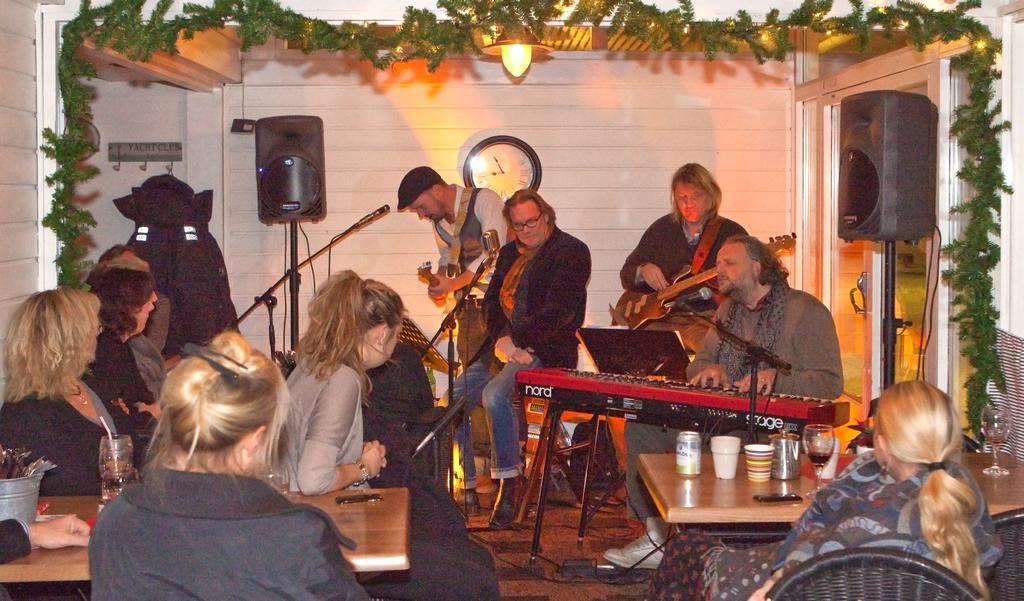In one or two sentences, can you explain what this image depicts? In the foreground of this image, there are women sitting on the chairs near tables on which there are glasses, cups, tin and few more objects on it. In the background, there are persons playing musical instruments in front of mics, a wall, clock, two speaker boxes, a light on the top and the coat to the hanger. On the top, there is an artificial creeper. 